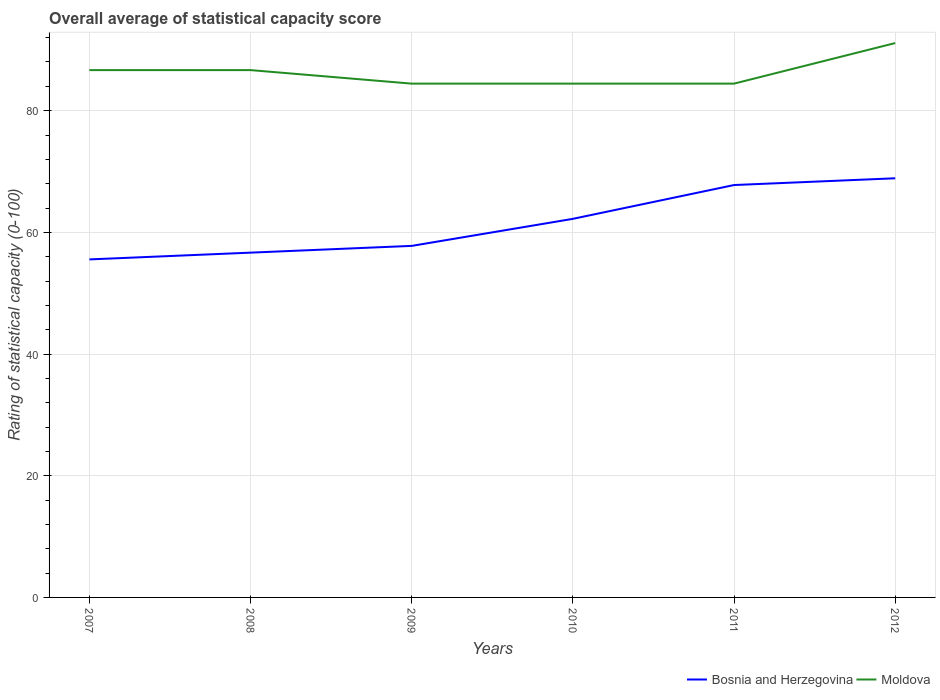Does the line corresponding to Moldova intersect with the line corresponding to Bosnia and Herzegovina?
Make the answer very short. No. Is the number of lines equal to the number of legend labels?
Ensure brevity in your answer.  Yes. Across all years, what is the maximum rating of statistical capacity in Bosnia and Herzegovina?
Ensure brevity in your answer.  55.56. In which year was the rating of statistical capacity in Moldova maximum?
Give a very brief answer. 2009. What is the total rating of statistical capacity in Moldova in the graph?
Your answer should be very brief. -6.67. What is the difference between the highest and the second highest rating of statistical capacity in Moldova?
Your response must be concise. 6.67. What is the difference between the highest and the lowest rating of statistical capacity in Moldova?
Your answer should be very brief. 3. How many lines are there?
Offer a very short reply. 2. How many years are there in the graph?
Offer a very short reply. 6. Are the values on the major ticks of Y-axis written in scientific E-notation?
Your answer should be very brief. No. How are the legend labels stacked?
Keep it short and to the point. Horizontal. What is the title of the graph?
Make the answer very short. Overall average of statistical capacity score. Does "Singapore" appear as one of the legend labels in the graph?
Offer a very short reply. No. What is the label or title of the X-axis?
Offer a very short reply. Years. What is the label or title of the Y-axis?
Your answer should be compact. Rating of statistical capacity (0-100). What is the Rating of statistical capacity (0-100) in Bosnia and Herzegovina in 2007?
Offer a very short reply. 55.56. What is the Rating of statistical capacity (0-100) of Moldova in 2007?
Provide a short and direct response. 86.67. What is the Rating of statistical capacity (0-100) in Bosnia and Herzegovina in 2008?
Offer a terse response. 56.67. What is the Rating of statistical capacity (0-100) of Moldova in 2008?
Offer a very short reply. 86.67. What is the Rating of statistical capacity (0-100) of Bosnia and Herzegovina in 2009?
Give a very brief answer. 57.78. What is the Rating of statistical capacity (0-100) of Moldova in 2009?
Your answer should be compact. 84.44. What is the Rating of statistical capacity (0-100) of Bosnia and Herzegovina in 2010?
Provide a short and direct response. 62.22. What is the Rating of statistical capacity (0-100) in Moldova in 2010?
Provide a short and direct response. 84.44. What is the Rating of statistical capacity (0-100) of Bosnia and Herzegovina in 2011?
Give a very brief answer. 67.78. What is the Rating of statistical capacity (0-100) in Moldova in 2011?
Give a very brief answer. 84.44. What is the Rating of statistical capacity (0-100) in Bosnia and Herzegovina in 2012?
Offer a very short reply. 68.89. What is the Rating of statistical capacity (0-100) in Moldova in 2012?
Keep it short and to the point. 91.11. Across all years, what is the maximum Rating of statistical capacity (0-100) of Bosnia and Herzegovina?
Your answer should be compact. 68.89. Across all years, what is the maximum Rating of statistical capacity (0-100) of Moldova?
Offer a terse response. 91.11. Across all years, what is the minimum Rating of statistical capacity (0-100) in Bosnia and Herzegovina?
Make the answer very short. 55.56. Across all years, what is the minimum Rating of statistical capacity (0-100) of Moldova?
Your response must be concise. 84.44. What is the total Rating of statistical capacity (0-100) of Bosnia and Herzegovina in the graph?
Offer a very short reply. 368.89. What is the total Rating of statistical capacity (0-100) in Moldova in the graph?
Your response must be concise. 517.78. What is the difference between the Rating of statistical capacity (0-100) of Bosnia and Herzegovina in 2007 and that in 2008?
Give a very brief answer. -1.11. What is the difference between the Rating of statistical capacity (0-100) in Bosnia and Herzegovina in 2007 and that in 2009?
Ensure brevity in your answer.  -2.22. What is the difference between the Rating of statistical capacity (0-100) of Moldova in 2007 and that in 2009?
Offer a terse response. 2.22. What is the difference between the Rating of statistical capacity (0-100) in Bosnia and Herzegovina in 2007 and that in 2010?
Ensure brevity in your answer.  -6.67. What is the difference between the Rating of statistical capacity (0-100) of Moldova in 2007 and that in 2010?
Give a very brief answer. 2.22. What is the difference between the Rating of statistical capacity (0-100) in Bosnia and Herzegovina in 2007 and that in 2011?
Offer a terse response. -12.22. What is the difference between the Rating of statistical capacity (0-100) in Moldova in 2007 and that in 2011?
Provide a succinct answer. 2.22. What is the difference between the Rating of statistical capacity (0-100) in Bosnia and Herzegovina in 2007 and that in 2012?
Keep it short and to the point. -13.33. What is the difference between the Rating of statistical capacity (0-100) in Moldova in 2007 and that in 2012?
Keep it short and to the point. -4.44. What is the difference between the Rating of statistical capacity (0-100) in Bosnia and Herzegovina in 2008 and that in 2009?
Give a very brief answer. -1.11. What is the difference between the Rating of statistical capacity (0-100) of Moldova in 2008 and that in 2009?
Your answer should be compact. 2.22. What is the difference between the Rating of statistical capacity (0-100) of Bosnia and Herzegovina in 2008 and that in 2010?
Provide a short and direct response. -5.56. What is the difference between the Rating of statistical capacity (0-100) in Moldova in 2008 and that in 2010?
Provide a succinct answer. 2.22. What is the difference between the Rating of statistical capacity (0-100) of Bosnia and Herzegovina in 2008 and that in 2011?
Provide a short and direct response. -11.11. What is the difference between the Rating of statistical capacity (0-100) of Moldova in 2008 and that in 2011?
Make the answer very short. 2.22. What is the difference between the Rating of statistical capacity (0-100) of Bosnia and Herzegovina in 2008 and that in 2012?
Your response must be concise. -12.22. What is the difference between the Rating of statistical capacity (0-100) of Moldova in 2008 and that in 2012?
Your answer should be very brief. -4.44. What is the difference between the Rating of statistical capacity (0-100) of Bosnia and Herzegovina in 2009 and that in 2010?
Give a very brief answer. -4.44. What is the difference between the Rating of statistical capacity (0-100) of Moldova in 2009 and that in 2011?
Your answer should be compact. 0. What is the difference between the Rating of statistical capacity (0-100) in Bosnia and Herzegovina in 2009 and that in 2012?
Offer a very short reply. -11.11. What is the difference between the Rating of statistical capacity (0-100) in Moldova in 2009 and that in 2012?
Offer a very short reply. -6.67. What is the difference between the Rating of statistical capacity (0-100) of Bosnia and Herzegovina in 2010 and that in 2011?
Make the answer very short. -5.56. What is the difference between the Rating of statistical capacity (0-100) of Bosnia and Herzegovina in 2010 and that in 2012?
Make the answer very short. -6.67. What is the difference between the Rating of statistical capacity (0-100) of Moldova in 2010 and that in 2012?
Offer a very short reply. -6.67. What is the difference between the Rating of statistical capacity (0-100) in Bosnia and Herzegovina in 2011 and that in 2012?
Provide a succinct answer. -1.11. What is the difference between the Rating of statistical capacity (0-100) of Moldova in 2011 and that in 2012?
Keep it short and to the point. -6.67. What is the difference between the Rating of statistical capacity (0-100) in Bosnia and Herzegovina in 2007 and the Rating of statistical capacity (0-100) in Moldova in 2008?
Your answer should be very brief. -31.11. What is the difference between the Rating of statistical capacity (0-100) in Bosnia and Herzegovina in 2007 and the Rating of statistical capacity (0-100) in Moldova in 2009?
Provide a short and direct response. -28.89. What is the difference between the Rating of statistical capacity (0-100) in Bosnia and Herzegovina in 2007 and the Rating of statistical capacity (0-100) in Moldova in 2010?
Offer a terse response. -28.89. What is the difference between the Rating of statistical capacity (0-100) of Bosnia and Herzegovina in 2007 and the Rating of statistical capacity (0-100) of Moldova in 2011?
Ensure brevity in your answer.  -28.89. What is the difference between the Rating of statistical capacity (0-100) in Bosnia and Herzegovina in 2007 and the Rating of statistical capacity (0-100) in Moldova in 2012?
Your response must be concise. -35.56. What is the difference between the Rating of statistical capacity (0-100) of Bosnia and Herzegovina in 2008 and the Rating of statistical capacity (0-100) of Moldova in 2009?
Ensure brevity in your answer.  -27.78. What is the difference between the Rating of statistical capacity (0-100) in Bosnia and Herzegovina in 2008 and the Rating of statistical capacity (0-100) in Moldova in 2010?
Keep it short and to the point. -27.78. What is the difference between the Rating of statistical capacity (0-100) in Bosnia and Herzegovina in 2008 and the Rating of statistical capacity (0-100) in Moldova in 2011?
Ensure brevity in your answer.  -27.78. What is the difference between the Rating of statistical capacity (0-100) in Bosnia and Herzegovina in 2008 and the Rating of statistical capacity (0-100) in Moldova in 2012?
Ensure brevity in your answer.  -34.44. What is the difference between the Rating of statistical capacity (0-100) of Bosnia and Herzegovina in 2009 and the Rating of statistical capacity (0-100) of Moldova in 2010?
Offer a terse response. -26.67. What is the difference between the Rating of statistical capacity (0-100) in Bosnia and Herzegovina in 2009 and the Rating of statistical capacity (0-100) in Moldova in 2011?
Offer a very short reply. -26.67. What is the difference between the Rating of statistical capacity (0-100) in Bosnia and Herzegovina in 2009 and the Rating of statistical capacity (0-100) in Moldova in 2012?
Offer a terse response. -33.33. What is the difference between the Rating of statistical capacity (0-100) of Bosnia and Herzegovina in 2010 and the Rating of statistical capacity (0-100) of Moldova in 2011?
Give a very brief answer. -22.22. What is the difference between the Rating of statistical capacity (0-100) in Bosnia and Herzegovina in 2010 and the Rating of statistical capacity (0-100) in Moldova in 2012?
Your response must be concise. -28.89. What is the difference between the Rating of statistical capacity (0-100) in Bosnia and Herzegovina in 2011 and the Rating of statistical capacity (0-100) in Moldova in 2012?
Provide a succinct answer. -23.33. What is the average Rating of statistical capacity (0-100) of Bosnia and Herzegovina per year?
Keep it short and to the point. 61.48. What is the average Rating of statistical capacity (0-100) of Moldova per year?
Your answer should be compact. 86.3. In the year 2007, what is the difference between the Rating of statistical capacity (0-100) in Bosnia and Herzegovina and Rating of statistical capacity (0-100) in Moldova?
Give a very brief answer. -31.11. In the year 2008, what is the difference between the Rating of statistical capacity (0-100) in Bosnia and Herzegovina and Rating of statistical capacity (0-100) in Moldova?
Make the answer very short. -30. In the year 2009, what is the difference between the Rating of statistical capacity (0-100) of Bosnia and Herzegovina and Rating of statistical capacity (0-100) of Moldova?
Offer a very short reply. -26.67. In the year 2010, what is the difference between the Rating of statistical capacity (0-100) in Bosnia and Herzegovina and Rating of statistical capacity (0-100) in Moldova?
Provide a short and direct response. -22.22. In the year 2011, what is the difference between the Rating of statistical capacity (0-100) in Bosnia and Herzegovina and Rating of statistical capacity (0-100) in Moldova?
Provide a short and direct response. -16.67. In the year 2012, what is the difference between the Rating of statistical capacity (0-100) of Bosnia and Herzegovina and Rating of statistical capacity (0-100) of Moldova?
Your answer should be very brief. -22.22. What is the ratio of the Rating of statistical capacity (0-100) in Bosnia and Herzegovina in 2007 to that in 2008?
Your answer should be very brief. 0.98. What is the ratio of the Rating of statistical capacity (0-100) of Bosnia and Herzegovina in 2007 to that in 2009?
Offer a terse response. 0.96. What is the ratio of the Rating of statistical capacity (0-100) in Moldova in 2007 to that in 2009?
Offer a terse response. 1.03. What is the ratio of the Rating of statistical capacity (0-100) in Bosnia and Herzegovina in 2007 to that in 2010?
Offer a very short reply. 0.89. What is the ratio of the Rating of statistical capacity (0-100) of Moldova in 2007 to that in 2010?
Your answer should be compact. 1.03. What is the ratio of the Rating of statistical capacity (0-100) in Bosnia and Herzegovina in 2007 to that in 2011?
Your response must be concise. 0.82. What is the ratio of the Rating of statistical capacity (0-100) in Moldova in 2007 to that in 2011?
Provide a short and direct response. 1.03. What is the ratio of the Rating of statistical capacity (0-100) of Bosnia and Herzegovina in 2007 to that in 2012?
Offer a very short reply. 0.81. What is the ratio of the Rating of statistical capacity (0-100) of Moldova in 2007 to that in 2012?
Make the answer very short. 0.95. What is the ratio of the Rating of statistical capacity (0-100) of Bosnia and Herzegovina in 2008 to that in 2009?
Provide a short and direct response. 0.98. What is the ratio of the Rating of statistical capacity (0-100) in Moldova in 2008 to that in 2009?
Provide a succinct answer. 1.03. What is the ratio of the Rating of statistical capacity (0-100) in Bosnia and Herzegovina in 2008 to that in 2010?
Your answer should be very brief. 0.91. What is the ratio of the Rating of statistical capacity (0-100) in Moldova in 2008 to that in 2010?
Provide a short and direct response. 1.03. What is the ratio of the Rating of statistical capacity (0-100) in Bosnia and Herzegovina in 2008 to that in 2011?
Provide a short and direct response. 0.84. What is the ratio of the Rating of statistical capacity (0-100) in Moldova in 2008 to that in 2011?
Provide a succinct answer. 1.03. What is the ratio of the Rating of statistical capacity (0-100) of Bosnia and Herzegovina in 2008 to that in 2012?
Offer a very short reply. 0.82. What is the ratio of the Rating of statistical capacity (0-100) in Moldova in 2008 to that in 2012?
Offer a very short reply. 0.95. What is the ratio of the Rating of statistical capacity (0-100) of Moldova in 2009 to that in 2010?
Ensure brevity in your answer.  1. What is the ratio of the Rating of statistical capacity (0-100) of Bosnia and Herzegovina in 2009 to that in 2011?
Ensure brevity in your answer.  0.85. What is the ratio of the Rating of statistical capacity (0-100) in Moldova in 2009 to that in 2011?
Provide a short and direct response. 1. What is the ratio of the Rating of statistical capacity (0-100) in Bosnia and Herzegovina in 2009 to that in 2012?
Ensure brevity in your answer.  0.84. What is the ratio of the Rating of statistical capacity (0-100) of Moldova in 2009 to that in 2012?
Your answer should be very brief. 0.93. What is the ratio of the Rating of statistical capacity (0-100) in Bosnia and Herzegovina in 2010 to that in 2011?
Offer a terse response. 0.92. What is the ratio of the Rating of statistical capacity (0-100) of Moldova in 2010 to that in 2011?
Your answer should be compact. 1. What is the ratio of the Rating of statistical capacity (0-100) of Bosnia and Herzegovina in 2010 to that in 2012?
Give a very brief answer. 0.9. What is the ratio of the Rating of statistical capacity (0-100) in Moldova in 2010 to that in 2012?
Ensure brevity in your answer.  0.93. What is the ratio of the Rating of statistical capacity (0-100) in Bosnia and Herzegovina in 2011 to that in 2012?
Your response must be concise. 0.98. What is the ratio of the Rating of statistical capacity (0-100) of Moldova in 2011 to that in 2012?
Offer a very short reply. 0.93. What is the difference between the highest and the second highest Rating of statistical capacity (0-100) in Bosnia and Herzegovina?
Offer a very short reply. 1.11. What is the difference between the highest and the second highest Rating of statistical capacity (0-100) of Moldova?
Provide a succinct answer. 4.44. What is the difference between the highest and the lowest Rating of statistical capacity (0-100) in Bosnia and Herzegovina?
Keep it short and to the point. 13.33. 